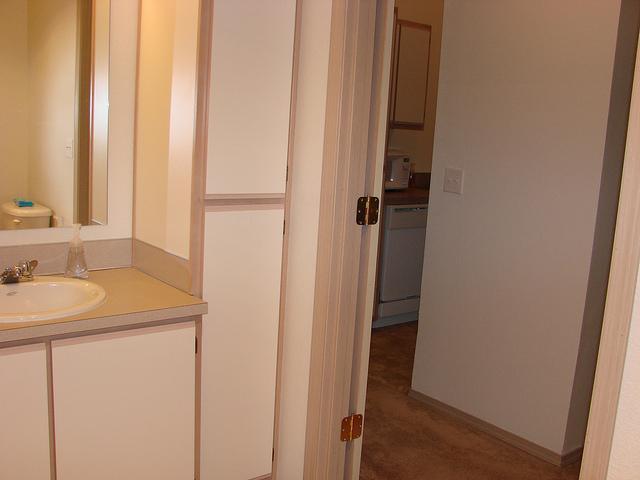How many mirrors are in this photo?
Give a very brief answer. 1. How many people in the picture are not wearing glasses?
Give a very brief answer. 0. 